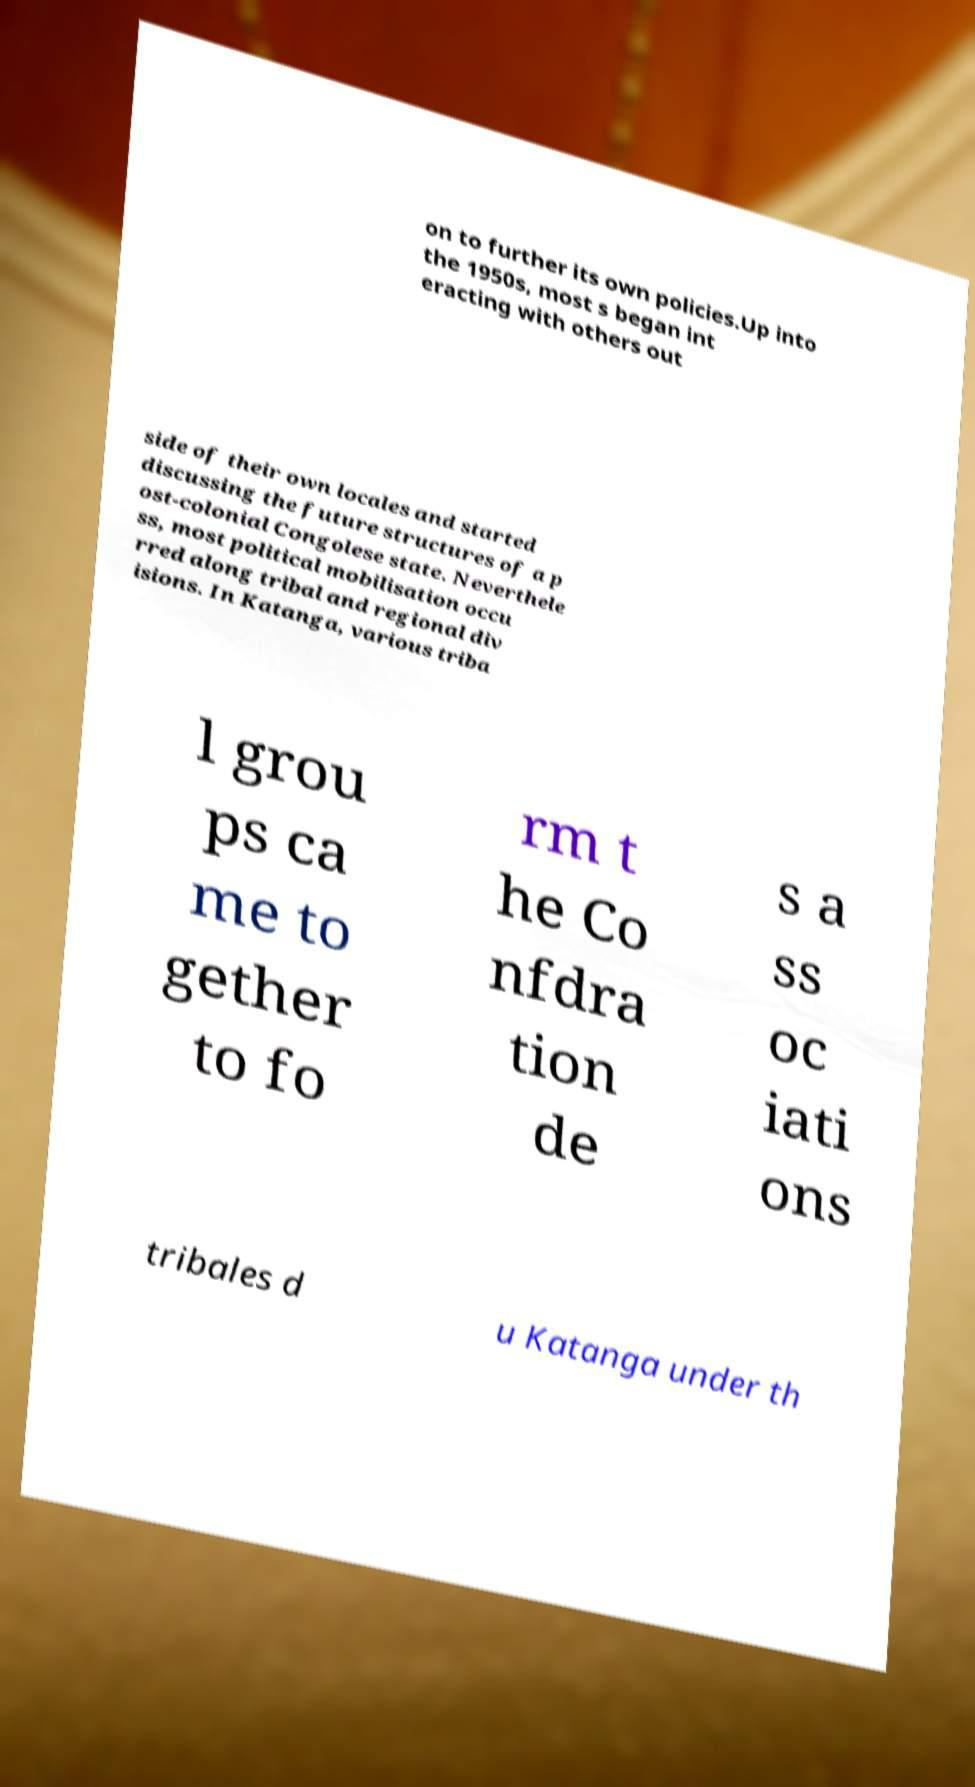Can you read and provide the text displayed in the image?This photo seems to have some interesting text. Can you extract and type it out for me? on to further its own policies.Up into the 1950s, most s began int eracting with others out side of their own locales and started discussing the future structures of a p ost-colonial Congolese state. Neverthele ss, most political mobilisation occu rred along tribal and regional div isions. In Katanga, various triba l grou ps ca me to gether to fo rm t he Co nfdra tion de s a ss oc iati ons tribales d u Katanga under th 